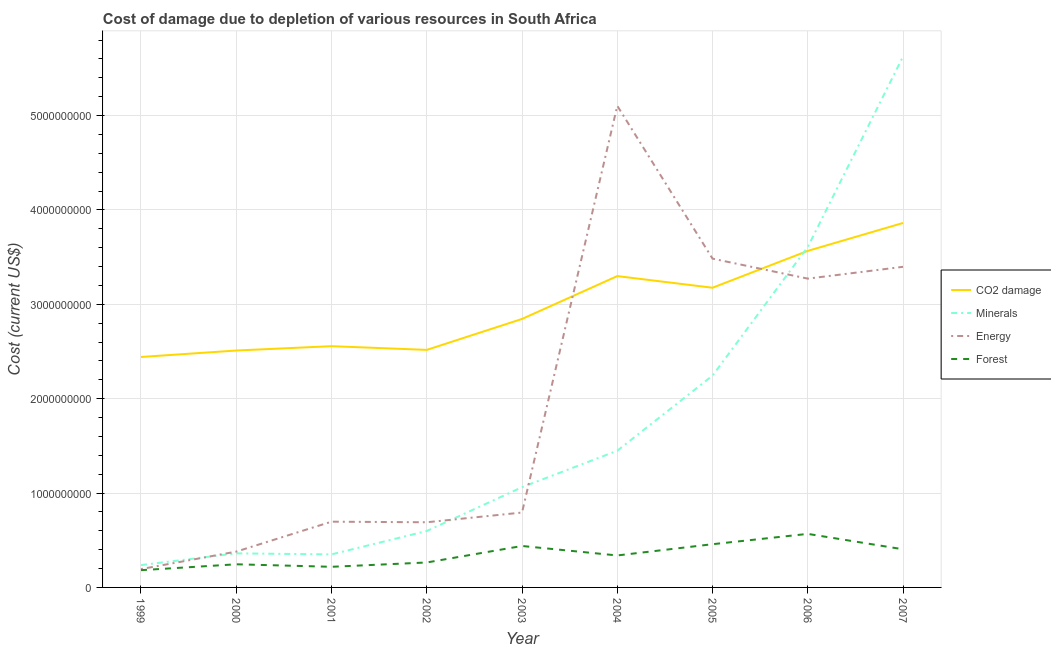Does the line corresponding to cost of damage due to depletion of forests intersect with the line corresponding to cost of damage due to depletion of coal?
Your response must be concise. No. What is the cost of damage due to depletion of minerals in 2006?
Provide a short and direct response. 3.61e+09. Across all years, what is the maximum cost of damage due to depletion of minerals?
Your answer should be compact. 5.63e+09. Across all years, what is the minimum cost of damage due to depletion of forests?
Keep it short and to the point. 1.83e+08. In which year was the cost of damage due to depletion of energy maximum?
Keep it short and to the point. 2004. What is the total cost of damage due to depletion of energy in the graph?
Your answer should be compact. 1.80e+1. What is the difference between the cost of damage due to depletion of minerals in 2001 and that in 2007?
Keep it short and to the point. -5.28e+09. What is the difference between the cost of damage due to depletion of minerals in 2000 and the cost of damage due to depletion of energy in 2005?
Provide a short and direct response. -3.12e+09. What is the average cost of damage due to depletion of minerals per year?
Your answer should be compact. 1.73e+09. In the year 2007, what is the difference between the cost of damage due to depletion of minerals and cost of damage due to depletion of energy?
Offer a very short reply. 2.23e+09. What is the ratio of the cost of damage due to depletion of coal in 2000 to that in 2005?
Make the answer very short. 0.79. Is the cost of damage due to depletion of energy in 2001 less than that in 2007?
Your answer should be compact. Yes. Is the difference between the cost of damage due to depletion of coal in 2004 and 2007 greater than the difference between the cost of damage due to depletion of energy in 2004 and 2007?
Your answer should be very brief. No. What is the difference between the highest and the second highest cost of damage due to depletion of minerals?
Your answer should be very brief. 2.02e+09. What is the difference between the highest and the lowest cost of damage due to depletion of coal?
Keep it short and to the point. 1.42e+09. Is the sum of the cost of damage due to depletion of energy in 2003 and 2005 greater than the maximum cost of damage due to depletion of minerals across all years?
Provide a short and direct response. No. Is it the case that in every year, the sum of the cost of damage due to depletion of coal and cost of damage due to depletion of forests is greater than the sum of cost of damage due to depletion of energy and cost of damage due to depletion of minerals?
Offer a terse response. No. Is it the case that in every year, the sum of the cost of damage due to depletion of coal and cost of damage due to depletion of minerals is greater than the cost of damage due to depletion of energy?
Make the answer very short. No. Is the cost of damage due to depletion of minerals strictly less than the cost of damage due to depletion of coal over the years?
Ensure brevity in your answer.  No. How many lines are there?
Keep it short and to the point. 4. Does the graph contain grids?
Provide a succinct answer. Yes. Where does the legend appear in the graph?
Provide a short and direct response. Center right. How many legend labels are there?
Your answer should be compact. 4. What is the title of the graph?
Ensure brevity in your answer.  Cost of damage due to depletion of various resources in South Africa . Does "Periodicity assessment" appear as one of the legend labels in the graph?
Your response must be concise. No. What is the label or title of the Y-axis?
Make the answer very short. Cost (current US$). What is the Cost (current US$) of CO2 damage in 1999?
Give a very brief answer. 2.44e+09. What is the Cost (current US$) in Minerals in 1999?
Provide a succinct answer. 2.37e+08. What is the Cost (current US$) of Energy in 1999?
Your answer should be very brief. 1.94e+08. What is the Cost (current US$) of Forest in 1999?
Ensure brevity in your answer.  1.83e+08. What is the Cost (current US$) of CO2 damage in 2000?
Your answer should be very brief. 2.51e+09. What is the Cost (current US$) of Minerals in 2000?
Give a very brief answer. 3.61e+08. What is the Cost (current US$) in Energy in 2000?
Make the answer very short. 3.80e+08. What is the Cost (current US$) of Forest in 2000?
Keep it short and to the point. 2.45e+08. What is the Cost (current US$) in CO2 damage in 2001?
Ensure brevity in your answer.  2.56e+09. What is the Cost (current US$) in Minerals in 2001?
Give a very brief answer. 3.50e+08. What is the Cost (current US$) of Energy in 2001?
Make the answer very short. 6.97e+08. What is the Cost (current US$) in Forest in 2001?
Provide a succinct answer. 2.19e+08. What is the Cost (current US$) in CO2 damage in 2002?
Give a very brief answer. 2.52e+09. What is the Cost (current US$) of Minerals in 2002?
Your answer should be compact. 5.98e+08. What is the Cost (current US$) in Energy in 2002?
Your answer should be compact. 6.91e+08. What is the Cost (current US$) in Forest in 2002?
Your answer should be compact. 2.64e+08. What is the Cost (current US$) in CO2 damage in 2003?
Your answer should be compact. 2.85e+09. What is the Cost (current US$) of Minerals in 2003?
Make the answer very short. 1.06e+09. What is the Cost (current US$) of Energy in 2003?
Provide a short and direct response. 7.94e+08. What is the Cost (current US$) in Forest in 2003?
Ensure brevity in your answer.  4.39e+08. What is the Cost (current US$) in CO2 damage in 2004?
Provide a succinct answer. 3.30e+09. What is the Cost (current US$) in Minerals in 2004?
Keep it short and to the point. 1.45e+09. What is the Cost (current US$) of Energy in 2004?
Make the answer very short. 5.10e+09. What is the Cost (current US$) of Forest in 2004?
Your response must be concise. 3.39e+08. What is the Cost (current US$) of CO2 damage in 2005?
Provide a short and direct response. 3.18e+09. What is the Cost (current US$) in Minerals in 2005?
Offer a very short reply. 2.24e+09. What is the Cost (current US$) in Energy in 2005?
Give a very brief answer. 3.48e+09. What is the Cost (current US$) of Forest in 2005?
Make the answer very short. 4.58e+08. What is the Cost (current US$) of CO2 damage in 2006?
Keep it short and to the point. 3.57e+09. What is the Cost (current US$) in Minerals in 2006?
Your answer should be compact. 3.61e+09. What is the Cost (current US$) of Energy in 2006?
Offer a terse response. 3.27e+09. What is the Cost (current US$) of Forest in 2006?
Offer a terse response. 5.67e+08. What is the Cost (current US$) in CO2 damage in 2007?
Your answer should be very brief. 3.86e+09. What is the Cost (current US$) in Minerals in 2007?
Your answer should be very brief. 5.63e+09. What is the Cost (current US$) in Energy in 2007?
Ensure brevity in your answer.  3.40e+09. What is the Cost (current US$) of Forest in 2007?
Give a very brief answer. 4.04e+08. Across all years, what is the maximum Cost (current US$) of CO2 damage?
Provide a succinct answer. 3.86e+09. Across all years, what is the maximum Cost (current US$) of Minerals?
Offer a very short reply. 5.63e+09. Across all years, what is the maximum Cost (current US$) in Energy?
Ensure brevity in your answer.  5.10e+09. Across all years, what is the maximum Cost (current US$) in Forest?
Your response must be concise. 5.67e+08. Across all years, what is the minimum Cost (current US$) in CO2 damage?
Ensure brevity in your answer.  2.44e+09. Across all years, what is the minimum Cost (current US$) in Minerals?
Your response must be concise. 2.37e+08. Across all years, what is the minimum Cost (current US$) of Energy?
Your answer should be compact. 1.94e+08. Across all years, what is the minimum Cost (current US$) in Forest?
Provide a succinct answer. 1.83e+08. What is the total Cost (current US$) of CO2 damage in the graph?
Offer a very short reply. 2.68e+1. What is the total Cost (current US$) in Minerals in the graph?
Ensure brevity in your answer.  1.55e+1. What is the total Cost (current US$) in Energy in the graph?
Keep it short and to the point. 1.80e+1. What is the total Cost (current US$) in Forest in the graph?
Offer a very short reply. 3.12e+09. What is the difference between the Cost (current US$) of CO2 damage in 1999 and that in 2000?
Give a very brief answer. -6.84e+07. What is the difference between the Cost (current US$) of Minerals in 1999 and that in 2000?
Offer a very short reply. -1.24e+08. What is the difference between the Cost (current US$) in Energy in 1999 and that in 2000?
Your answer should be compact. -1.85e+08. What is the difference between the Cost (current US$) in Forest in 1999 and that in 2000?
Your answer should be compact. -6.24e+07. What is the difference between the Cost (current US$) of CO2 damage in 1999 and that in 2001?
Your answer should be very brief. -1.14e+08. What is the difference between the Cost (current US$) of Minerals in 1999 and that in 2001?
Provide a succinct answer. -1.13e+08. What is the difference between the Cost (current US$) in Energy in 1999 and that in 2001?
Offer a terse response. -5.02e+08. What is the difference between the Cost (current US$) in Forest in 1999 and that in 2001?
Your answer should be compact. -3.59e+07. What is the difference between the Cost (current US$) in CO2 damage in 1999 and that in 2002?
Provide a succinct answer. -7.52e+07. What is the difference between the Cost (current US$) of Minerals in 1999 and that in 2002?
Keep it short and to the point. -3.61e+08. What is the difference between the Cost (current US$) of Energy in 1999 and that in 2002?
Offer a very short reply. -4.96e+08. What is the difference between the Cost (current US$) of Forest in 1999 and that in 2002?
Offer a very short reply. -8.16e+07. What is the difference between the Cost (current US$) of CO2 damage in 1999 and that in 2003?
Your answer should be very brief. -4.03e+08. What is the difference between the Cost (current US$) in Minerals in 1999 and that in 2003?
Provide a succinct answer. -8.25e+08. What is the difference between the Cost (current US$) of Energy in 1999 and that in 2003?
Your response must be concise. -5.99e+08. What is the difference between the Cost (current US$) in Forest in 1999 and that in 2003?
Your answer should be very brief. -2.56e+08. What is the difference between the Cost (current US$) in CO2 damage in 1999 and that in 2004?
Give a very brief answer. -8.57e+08. What is the difference between the Cost (current US$) in Minerals in 1999 and that in 2004?
Your answer should be compact. -1.21e+09. What is the difference between the Cost (current US$) in Energy in 1999 and that in 2004?
Keep it short and to the point. -4.91e+09. What is the difference between the Cost (current US$) of Forest in 1999 and that in 2004?
Ensure brevity in your answer.  -1.56e+08. What is the difference between the Cost (current US$) of CO2 damage in 1999 and that in 2005?
Offer a terse response. -7.34e+08. What is the difference between the Cost (current US$) of Minerals in 1999 and that in 2005?
Ensure brevity in your answer.  -2.01e+09. What is the difference between the Cost (current US$) of Energy in 1999 and that in 2005?
Your response must be concise. -3.29e+09. What is the difference between the Cost (current US$) in Forest in 1999 and that in 2005?
Offer a very short reply. -2.75e+08. What is the difference between the Cost (current US$) in CO2 damage in 1999 and that in 2006?
Keep it short and to the point. -1.12e+09. What is the difference between the Cost (current US$) of Minerals in 1999 and that in 2006?
Your answer should be very brief. -3.37e+09. What is the difference between the Cost (current US$) of Energy in 1999 and that in 2006?
Your response must be concise. -3.08e+09. What is the difference between the Cost (current US$) of Forest in 1999 and that in 2006?
Ensure brevity in your answer.  -3.85e+08. What is the difference between the Cost (current US$) of CO2 damage in 1999 and that in 2007?
Offer a terse response. -1.42e+09. What is the difference between the Cost (current US$) in Minerals in 1999 and that in 2007?
Give a very brief answer. -5.39e+09. What is the difference between the Cost (current US$) in Energy in 1999 and that in 2007?
Your response must be concise. -3.20e+09. What is the difference between the Cost (current US$) of Forest in 1999 and that in 2007?
Your answer should be compact. -2.21e+08. What is the difference between the Cost (current US$) in CO2 damage in 2000 and that in 2001?
Make the answer very short. -4.60e+07. What is the difference between the Cost (current US$) in Minerals in 2000 and that in 2001?
Keep it short and to the point. 1.09e+07. What is the difference between the Cost (current US$) of Energy in 2000 and that in 2001?
Offer a terse response. -3.17e+08. What is the difference between the Cost (current US$) of Forest in 2000 and that in 2001?
Give a very brief answer. 2.66e+07. What is the difference between the Cost (current US$) of CO2 damage in 2000 and that in 2002?
Your answer should be very brief. -6.77e+06. What is the difference between the Cost (current US$) of Minerals in 2000 and that in 2002?
Provide a short and direct response. -2.37e+08. What is the difference between the Cost (current US$) of Energy in 2000 and that in 2002?
Give a very brief answer. -3.11e+08. What is the difference between the Cost (current US$) of Forest in 2000 and that in 2002?
Your answer should be compact. -1.91e+07. What is the difference between the Cost (current US$) in CO2 damage in 2000 and that in 2003?
Give a very brief answer. -3.35e+08. What is the difference between the Cost (current US$) in Minerals in 2000 and that in 2003?
Provide a short and direct response. -7.01e+08. What is the difference between the Cost (current US$) of Energy in 2000 and that in 2003?
Offer a very short reply. -4.14e+08. What is the difference between the Cost (current US$) in Forest in 2000 and that in 2003?
Your response must be concise. -1.94e+08. What is the difference between the Cost (current US$) in CO2 damage in 2000 and that in 2004?
Offer a very short reply. -7.89e+08. What is the difference between the Cost (current US$) in Minerals in 2000 and that in 2004?
Offer a terse response. -1.09e+09. What is the difference between the Cost (current US$) of Energy in 2000 and that in 2004?
Your answer should be compact. -4.72e+09. What is the difference between the Cost (current US$) of Forest in 2000 and that in 2004?
Make the answer very short. -9.36e+07. What is the difference between the Cost (current US$) of CO2 damage in 2000 and that in 2005?
Your answer should be compact. -6.65e+08. What is the difference between the Cost (current US$) in Minerals in 2000 and that in 2005?
Your answer should be compact. -1.88e+09. What is the difference between the Cost (current US$) in Energy in 2000 and that in 2005?
Make the answer very short. -3.10e+09. What is the difference between the Cost (current US$) of Forest in 2000 and that in 2005?
Provide a succinct answer. -2.13e+08. What is the difference between the Cost (current US$) in CO2 damage in 2000 and that in 2006?
Provide a succinct answer. -1.06e+09. What is the difference between the Cost (current US$) in Minerals in 2000 and that in 2006?
Ensure brevity in your answer.  -3.25e+09. What is the difference between the Cost (current US$) of Energy in 2000 and that in 2006?
Your response must be concise. -2.89e+09. What is the difference between the Cost (current US$) of Forest in 2000 and that in 2006?
Provide a short and direct response. -3.22e+08. What is the difference between the Cost (current US$) of CO2 damage in 2000 and that in 2007?
Offer a very short reply. -1.35e+09. What is the difference between the Cost (current US$) of Minerals in 2000 and that in 2007?
Provide a short and direct response. -5.27e+09. What is the difference between the Cost (current US$) of Energy in 2000 and that in 2007?
Ensure brevity in your answer.  -3.02e+09. What is the difference between the Cost (current US$) of Forest in 2000 and that in 2007?
Provide a short and direct response. -1.59e+08. What is the difference between the Cost (current US$) of CO2 damage in 2001 and that in 2002?
Provide a succinct answer. 3.92e+07. What is the difference between the Cost (current US$) of Minerals in 2001 and that in 2002?
Make the answer very short. -2.48e+08. What is the difference between the Cost (current US$) of Energy in 2001 and that in 2002?
Your answer should be compact. 6.14e+06. What is the difference between the Cost (current US$) in Forest in 2001 and that in 2002?
Make the answer very short. -4.57e+07. What is the difference between the Cost (current US$) of CO2 damage in 2001 and that in 2003?
Your answer should be very brief. -2.89e+08. What is the difference between the Cost (current US$) in Minerals in 2001 and that in 2003?
Ensure brevity in your answer.  -7.12e+08. What is the difference between the Cost (current US$) of Energy in 2001 and that in 2003?
Provide a short and direct response. -9.69e+07. What is the difference between the Cost (current US$) of Forest in 2001 and that in 2003?
Provide a short and direct response. -2.21e+08. What is the difference between the Cost (current US$) in CO2 damage in 2001 and that in 2004?
Offer a very short reply. -7.43e+08. What is the difference between the Cost (current US$) in Minerals in 2001 and that in 2004?
Offer a terse response. -1.10e+09. What is the difference between the Cost (current US$) in Energy in 2001 and that in 2004?
Give a very brief answer. -4.41e+09. What is the difference between the Cost (current US$) of Forest in 2001 and that in 2004?
Provide a succinct answer. -1.20e+08. What is the difference between the Cost (current US$) in CO2 damage in 2001 and that in 2005?
Provide a succinct answer. -6.19e+08. What is the difference between the Cost (current US$) of Minerals in 2001 and that in 2005?
Provide a short and direct response. -1.89e+09. What is the difference between the Cost (current US$) of Energy in 2001 and that in 2005?
Offer a terse response. -2.79e+09. What is the difference between the Cost (current US$) in Forest in 2001 and that in 2005?
Make the answer very short. -2.39e+08. What is the difference between the Cost (current US$) in CO2 damage in 2001 and that in 2006?
Make the answer very short. -1.01e+09. What is the difference between the Cost (current US$) in Minerals in 2001 and that in 2006?
Ensure brevity in your answer.  -3.26e+09. What is the difference between the Cost (current US$) of Energy in 2001 and that in 2006?
Give a very brief answer. -2.58e+09. What is the difference between the Cost (current US$) of Forest in 2001 and that in 2006?
Your answer should be very brief. -3.49e+08. What is the difference between the Cost (current US$) of CO2 damage in 2001 and that in 2007?
Your answer should be compact. -1.31e+09. What is the difference between the Cost (current US$) in Minerals in 2001 and that in 2007?
Keep it short and to the point. -5.28e+09. What is the difference between the Cost (current US$) in Energy in 2001 and that in 2007?
Offer a terse response. -2.70e+09. What is the difference between the Cost (current US$) in Forest in 2001 and that in 2007?
Ensure brevity in your answer.  -1.85e+08. What is the difference between the Cost (current US$) in CO2 damage in 2002 and that in 2003?
Offer a terse response. -3.28e+08. What is the difference between the Cost (current US$) in Minerals in 2002 and that in 2003?
Your answer should be very brief. -4.64e+08. What is the difference between the Cost (current US$) in Energy in 2002 and that in 2003?
Ensure brevity in your answer.  -1.03e+08. What is the difference between the Cost (current US$) in Forest in 2002 and that in 2003?
Your response must be concise. -1.75e+08. What is the difference between the Cost (current US$) in CO2 damage in 2002 and that in 2004?
Ensure brevity in your answer.  -7.82e+08. What is the difference between the Cost (current US$) of Minerals in 2002 and that in 2004?
Your response must be concise. -8.51e+08. What is the difference between the Cost (current US$) in Energy in 2002 and that in 2004?
Make the answer very short. -4.41e+09. What is the difference between the Cost (current US$) of Forest in 2002 and that in 2004?
Offer a very short reply. -7.44e+07. What is the difference between the Cost (current US$) of CO2 damage in 2002 and that in 2005?
Give a very brief answer. -6.59e+08. What is the difference between the Cost (current US$) of Minerals in 2002 and that in 2005?
Offer a terse response. -1.65e+09. What is the difference between the Cost (current US$) in Energy in 2002 and that in 2005?
Your response must be concise. -2.79e+09. What is the difference between the Cost (current US$) in Forest in 2002 and that in 2005?
Keep it short and to the point. -1.94e+08. What is the difference between the Cost (current US$) in CO2 damage in 2002 and that in 2006?
Give a very brief answer. -1.05e+09. What is the difference between the Cost (current US$) in Minerals in 2002 and that in 2006?
Offer a very short reply. -3.01e+09. What is the difference between the Cost (current US$) in Energy in 2002 and that in 2006?
Give a very brief answer. -2.58e+09. What is the difference between the Cost (current US$) of Forest in 2002 and that in 2006?
Your response must be concise. -3.03e+08. What is the difference between the Cost (current US$) in CO2 damage in 2002 and that in 2007?
Your answer should be compact. -1.34e+09. What is the difference between the Cost (current US$) in Minerals in 2002 and that in 2007?
Keep it short and to the point. -5.03e+09. What is the difference between the Cost (current US$) of Energy in 2002 and that in 2007?
Provide a succinct answer. -2.71e+09. What is the difference between the Cost (current US$) in Forest in 2002 and that in 2007?
Give a very brief answer. -1.40e+08. What is the difference between the Cost (current US$) of CO2 damage in 2003 and that in 2004?
Provide a succinct answer. -4.54e+08. What is the difference between the Cost (current US$) in Minerals in 2003 and that in 2004?
Provide a succinct answer. -3.87e+08. What is the difference between the Cost (current US$) of Energy in 2003 and that in 2004?
Ensure brevity in your answer.  -4.31e+09. What is the difference between the Cost (current US$) of Forest in 2003 and that in 2004?
Provide a succinct answer. 1.00e+08. What is the difference between the Cost (current US$) of CO2 damage in 2003 and that in 2005?
Provide a short and direct response. -3.31e+08. What is the difference between the Cost (current US$) of Minerals in 2003 and that in 2005?
Give a very brief answer. -1.18e+09. What is the difference between the Cost (current US$) of Energy in 2003 and that in 2005?
Give a very brief answer. -2.69e+09. What is the difference between the Cost (current US$) of Forest in 2003 and that in 2005?
Your answer should be compact. -1.89e+07. What is the difference between the Cost (current US$) in CO2 damage in 2003 and that in 2006?
Give a very brief answer. -7.21e+08. What is the difference between the Cost (current US$) in Minerals in 2003 and that in 2006?
Give a very brief answer. -2.55e+09. What is the difference between the Cost (current US$) in Energy in 2003 and that in 2006?
Provide a short and direct response. -2.48e+09. What is the difference between the Cost (current US$) of Forest in 2003 and that in 2006?
Keep it short and to the point. -1.28e+08. What is the difference between the Cost (current US$) of CO2 damage in 2003 and that in 2007?
Make the answer very short. -1.02e+09. What is the difference between the Cost (current US$) of Minerals in 2003 and that in 2007?
Your response must be concise. -4.56e+09. What is the difference between the Cost (current US$) in Energy in 2003 and that in 2007?
Provide a succinct answer. -2.60e+09. What is the difference between the Cost (current US$) of Forest in 2003 and that in 2007?
Offer a terse response. 3.50e+07. What is the difference between the Cost (current US$) of CO2 damage in 2004 and that in 2005?
Keep it short and to the point. 1.23e+08. What is the difference between the Cost (current US$) in Minerals in 2004 and that in 2005?
Keep it short and to the point. -7.96e+08. What is the difference between the Cost (current US$) in Energy in 2004 and that in 2005?
Ensure brevity in your answer.  1.62e+09. What is the difference between the Cost (current US$) in Forest in 2004 and that in 2005?
Provide a succinct answer. -1.19e+08. What is the difference between the Cost (current US$) in CO2 damage in 2004 and that in 2006?
Your response must be concise. -2.67e+08. What is the difference between the Cost (current US$) of Minerals in 2004 and that in 2006?
Your answer should be very brief. -2.16e+09. What is the difference between the Cost (current US$) in Energy in 2004 and that in 2006?
Your answer should be very brief. 1.83e+09. What is the difference between the Cost (current US$) in Forest in 2004 and that in 2006?
Ensure brevity in your answer.  -2.29e+08. What is the difference between the Cost (current US$) of CO2 damage in 2004 and that in 2007?
Provide a short and direct response. -5.63e+08. What is the difference between the Cost (current US$) in Minerals in 2004 and that in 2007?
Make the answer very short. -4.18e+09. What is the difference between the Cost (current US$) of Energy in 2004 and that in 2007?
Offer a very short reply. 1.71e+09. What is the difference between the Cost (current US$) of Forest in 2004 and that in 2007?
Your answer should be compact. -6.54e+07. What is the difference between the Cost (current US$) in CO2 damage in 2005 and that in 2006?
Provide a succinct answer. -3.91e+08. What is the difference between the Cost (current US$) in Minerals in 2005 and that in 2006?
Offer a terse response. -1.36e+09. What is the difference between the Cost (current US$) of Energy in 2005 and that in 2006?
Your answer should be very brief. 2.12e+08. What is the difference between the Cost (current US$) of Forest in 2005 and that in 2006?
Give a very brief answer. -1.09e+08. What is the difference between the Cost (current US$) in CO2 damage in 2005 and that in 2007?
Make the answer very short. -6.86e+08. What is the difference between the Cost (current US$) of Minerals in 2005 and that in 2007?
Offer a terse response. -3.38e+09. What is the difference between the Cost (current US$) in Energy in 2005 and that in 2007?
Ensure brevity in your answer.  8.63e+07. What is the difference between the Cost (current US$) in Forest in 2005 and that in 2007?
Provide a short and direct response. 5.39e+07. What is the difference between the Cost (current US$) of CO2 damage in 2006 and that in 2007?
Your response must be concise. -2.96e+08. What is the difference between the Cost (current US$) of Minerals in 2006 and that in 2007?
Give a very brief answer. -2.02e+09. What is the difference between the Cost (current US$) of Energy in 2006 and that in 2007?
Provide a succinct answer. -1.25e+08. What is the difference between the Cost (current US$) in Forest in 2006 and that in 2007?
Make the answer very short. 1.63e+08. What is the difference between the Cost (current US$) in CO2 damage in 1999 and the Cost (current US$) in Minerals in 2000?
Your answer should be compact. 2.08e+09. What is the difference between the Cost (current US$) of CO2 damage in 1999 and the Cost (current US$) of Energy in 2000?
Make the answer very short. 2.06e+09. What is the difference between the Cost (current US$) of CO2 damage in 1999 and the Cost (current US$) of Forest in 2000?
Keep it short and to the point. 2.20e+09. What is the difference between the Cost (current US$) of Minerals in 1999 and the Cost (current US$) of Energy in 2000?
Your answer should be very brief. -1.43e+08. What is the difference between the Cost (current US$) of Minerals in 1999 and the Cost (current US$) of Forest in 2000?
Provide a succinct answer. -8.40e+06. What is the difference between the Cost (current US$) in Energy in 1999 and the Cost (current US$) in Forest in 2000?
Provide a short and direct response. -5.09e+07. What is the difference between the Cost (current US$) of CO2 damage in 1999 and the Cost (current US$) of Minerals in 2001?
Provide a short and direct response. 2.09e+09. What is the difference between the Cost (current US$) in CO2 damage in 1999 and the Cost (current US$) in Energy in 2001?
Give a very brief answer. 1.75e+09. What is the difference between the Cost (current US$) in CO2 damage in 1999 and the Cost (current US$) in Forest in 2001?
Make the answer very short. 2.22e+09. What is the difference between the Cost (current US$) of Minerals in 1999 and the Cost (current US$) of Energy in 2001?
Your answer should be very brief. -4.60e+08. What is the difference between the Cost (current US$) in Minerals in 1999 and the Cost (current US$) in Forest in 2001?
Your answer should be very brief. 1.82e+07. What is the difference between the Cost (current US$) of Energy in 1999 and the Cost (current US$) of Forest in 2001?
Offer a terse response. -2.43e+07. What is the difference between the Cost (current US$) in CO2 damage in 1999 and the Cost (current US$) in Minerals in 2002?
Provide a succinct answer. 1.84e+09. What is the difference between the Cost (current US$) of CO2 damage in 1999 and the Cost (current US$) of Energy in 2002?
Ensure brevity in your answer.  1.75e+09. What is the difference between the Cost (current US$) in CO2 damage in 1999 and the Cost (current US$) in Forest in 2002?
Provide a succinct answer. 2.18e+09. What is the difference between the Cost (current US$) in Minerals in 1999 and the Cost (current US$) in Energy in 2002?
Provide a succinct answer. -4.54e+08. What is the difference between the Cost (current US$) in Minerals in 1999 and the Cost (current US$) in Forest in 2002?
Give a very brief answer. -2.76e+07. What is the difference between the Cost (current US$) of Energy in 1999 and the Cost (current US$) of Forest in 2002?
Provide a short and direct response. -7.00e+07. What is the difference between the Cost (current US$) of CO2 damage in 1999 and the Cost (current US$) of Minerals in 2003?
Provide a short and direct response. 1.38e+09. What is the difference between the Cost (current US$) in CO2 damage in 1999 and the Cost (current US$) in Energy in 2003?
Provide a short and direct response. 1.65e+09. What is the difference between the Cost (current US$) in CO2 damage in 1999 and the Cost (current US$) in Forest in 2003?
Give a very brief answer. 2.00e+09. What is the difference between the Cost (current US$) of Minerals in 1999 and the Cost (current US$) of Energy in 2003?
Offer a very short reply. -5.57e+08. What is the difference between the Cost (current US$) of Minerals in 1999 and the Cost (current US$) of Forest in 2003?
Your answer should be compact. -2.02e+08. What is the difference between the Cost (current US$) of Energy in 1999 and the Cost (current US$) of Forest in 2003?
Give a very brief answer. -2.45e+08. What is the difference between the Cost (current US$) of CO2 damage in 1999 and the Cost (current US$) of Minerals in 2004?
Your answer should be very brief. 9.93e+08. What is the difference between the Cost (current US$) of CO2 damage in 1999 and the Cost (current US$) of Energy in 2004?
Your answer should be very brief. -2.66e+09. What is the difference between the Cost (current US$) in CO2 damage in 1999 and the Cost (current US$) in Forest in 2004?
Offer a very short reply. 2.10e+09. What is the difference between the Cost (current US$) of Minerals in 1999 and the Cost (current US$) of Energy in 2004?
Offer a terse response. -4.87e+09. What is the difference between the Cost (current US$) in Minerals in 1999 and the Cost (current US$) in Forest in 2004?
Give a very brief answer. -1.02e+08. What is the difference between the Cost (current US$) of Energy in 1999 and the Cost (current US$) of Forest in 2004?
Provide a short and direct response. -1.44e+08. What is the difference between the Cost (current US$) in CO2 damage in 1999 and the Cost (current US$) in Minerals in 2005?
Your answer should be very brief. 1.98e+08. What is the difference between the Cost (current US$) in CO2 damage in 1999 and the Cost (current US$) in Energy in 2005?
Make the answer very short. -1.04e+09. What is the difference between the Cost (current US$) of CO2 damage in 1999 and the Cost (current US$) of Forest in 2005?
Ensure brevity in your answer.  1.98e+09. What is the difference between the Cost (current US$) of Minerals in 1999 and the Cost (current US$) of Energy in 2005?
Provide a short and direct response. -3.25e+09. What is the difference between the Cost (current US$) of Minerals in 1999 and the Cost (current US$) of Forest in 2005?
Offer a terse response. -2.21e+08. What is the difference between the Cost (current US$) of Energy in 1999 and the Cost (current US$) of Forest in 2005?
Keep it short and to the point. -2.64e+08. What is the difference between the Cost (current US$) in CO2 damage in 1999 and the Cost (current US$) in Minerals in 2006?
Give a very brief answer. -1.17e+09. What is the difference between the Cost (current US$) of CO2 damage in 1999 and the Cost (current US$) of Energy in 2006?
Keep it short and to the point. -8.30e+08. What is the difference between the Cost (current US$) of CO2 damage in 1999 and the Cost (current US$) of Forest in 2006?
Ensure brevity in your answer.  1.87e+09. What is the difference between the Cost (current US$) of Minerals in 1999 and the Cost (current US$) of Energy in 2006?
Ensure brevity in your answer.  -3.04e+09. What is the difference between the Cost (current US$) of Minerals in 1999 and the Cost (current US$) of Forest in 2006?
Provide a short and direct response. -3.31e+08. What is the difference between the Cost (current US$) in Energy in 1999 and the Cost (current US$) in Forest in 2006?
Offer a very short reply. -3.73e+08. What is the difference between the Cost (current US$) of CO2 damage in 1999 and the Cost (current US$) of Minerals in 2007?
Provide a short and direct response. -3.18e+09. What is the difference between the Cost (current US$) of CO2 damage in 1999 and the Cost (current US$) of Energy in 2007?
Ensure brevity in your answer.  -9.56e+08. What is the difference between the Cost (current US$) in CO2 damage in 1999 and the Cost (current US$) in Forest in 2007?
Your answer should be compact. 2.04e+09. What is the difference between the Cost (current US$) in Minerals in 1999 and the Cost (current US$) in Energy in 2007?
Make the answer very short. -3.16e+09. What is the difference between the Cost (current US$) of Minerals in 1999 and the Cost (current US$) of Forest in 2007?
Your answer should be very brief. -1.67e+08. What is the difference between the Cost (current US$) in Energy in 1999 and the Cost (current US$) in Forest in 2007?
Give a very brief answer. -2.10e+08. What is the difference between the Cost (current US$) in CO2 damage in 2000 and the Cost (current US$) in Minerals in 2001?
Ensure brevity in your answer.  2.16e+09. What is the difference between the Cost (current US$) in CO2 damage in 2000 and the Cost (current US$) in Energy in 2001?
Keep it short and to the point. 1.81e+09. What is the difference between the Cost (current US$) in CO2 damage in 2000 and the Cost (current US$) in Forest in 2001?
Your response must be concise. 2.29e+09. What is the difference between the Cost (current US$) in Minerals in 2000 and the Cost (current US$) in Energy in 2001?
Your answer should be very brief. -3.36e+08. What is the difference between the Cost (current US$) in Minerals in 2000 and the Cost (current US$) in Forest in 2001?
Provide a short and direct response. 1.42e+08. What is the difference between the Cost (current US$) in Energy in 2000 and the Cost (current US$) in Forest in 2001?
Provide a succinct answer. 1.61e+08. What is the difference between the Cost (current US$) in CO2 damage in 2000 and the Cost (current US$) in Minerals in 2002?
Keep it short and to the point. 1.91e+09. What is the difference between the Cost (current US$) of CO2 damage in 2000 and the Cost (current US$) of Energy in 2002?
Keep it short and to the point. 1.82e+09. What is the difference between the Cost (current US$) of CO2 damage in 2000 and the Cost (current US$) of Forest in 2002?
Your response must be concise. 2.25e+09. What is the difference between the Cost (current US$) in Minerals in 2000 and the Cost (current US$) in Energy in 2002?
Provide a short and direct response. -3.30e+08. What is the difference between the Cost (current US$) in Minerals in 2000 and the Cost (current US$) in Forest in 2002?
Give a very brief answer. 9.66e+07. What is the difference between the Cost (current US$) of Energy in 2000 and the Cost (current US$) of Forest in 2002?
Offer a very short reply. 1.15e+08. What is the difference between the Cost (current US$) in CO2 damage in 2000 and the Cost (current US$) in Minerals in 2003?
Offer a very short reply. 1.45e+09. What is the difference between the Cost (current US$) of CO2 damage in 2000 and the Cost (current US$) of Energy in 2003?
Give a very brief answer. 1.72e+09. What is the difference between the Cost (current US$) of CO2 damage in 2000 and the Cost (current US$) of Forest in 2003?
Your answer should be very brief. 2.07e+09. What is the difference between the Cost (current US$) of Minerals in 2000 and the Cost (current US$) of Energy in 2003?
Your answer should be very brief. -4.33e+08. What is the difference between the Cost (current US$) in Minerals in 2000 and the Cost (current US$) in Forest in 2003?
Offer a terse response. -7.82e+07. What is the difference between the Cost (current US$) of Energy in 2000 and the Cost (current US$) of Forest in 2003?
Provide a succinct answer. -5.95e+07. What is the difference between the Cost (current US$) in CO2 damage in 2000 and the Cost (current US$) in Minerals in 2004?
Offer a terse response. 1.06e+09. What is the difference between the Cost (current US$) of CO2 damage in 2000 and the Cost (current US$) of Energy in 2004?
Provide a short and direct response. -2.59e+09. What is the difference between the Cost (current US$) in CO2 damage in 2000 and the Cost (current US$) in Forest in 2004?
Offer a very short reply. 2.17e+09. What is the difference between the Cost (current US$) of Minerals in 2000 and the Cost (current US$) of Energy in 2004?
Your answer should be compact. -4.74e+09. What is the difference between the Cost (current US$) of Minerals in 2000 and the Cost (current US$) of Forest in 2004?
Ensure brevity in your answer.  2.22e+07. What is the difference between the Cost (current US$) in Energy in 2000 and the Cost (current US$) in Forest in 2004?
Ensure brevity in your answer.  4.08e+07. What is the difference between the Cost (current US$) in CO2 damage in 2000 and the Cost (current US$) in Minerals in 2005?
Keep it short and to the point. 2.66e+08. What is the difference between the Cost (current US$) of CO2 damage in 2000 and the Cost (current US$) of Energy in 2005?
Your answer should be very brief. -9.73e+08. What is the difference between the Cost (current US$) in CO2 damage in 2000 and the Cost (current US$) in Forest in 2005?
Provide a short and direct response. 2.05e+09. What is the difference between the Cost (current US$) in Minerals in 2000 and the Cost (current US$) in Energy in 2005?
Ensure brevity in your answer.  -3.12e+09. What is the difference between the Cost (current US$) of Minerals in 2000 and the Cost (current US$) of Forest in 2005?
Your answer should be very brief. -9.71e+07. What is the difference between the Cost (current US$) in Energy in 2000 and the Cost (current US$) in Forest in 2005?
Your response must be concise. -7.84e+07. What is the difference between the Cost (current US$) of CO2 damage in 2000 and the Cost (current US$) of Minerals in 2006?
Provide a succinct answer. -1.10e+09. What is the difference between the Cost (current US$) of CO2 damage in 2000 and the Cost (current US$) of Energy in 2006?
Offer a terse response. -7.62e+08. What is the difference between the Cost (current US$) of CO2 damage in 2000 and the Cost (current US$) of Forest in 2006?
Give a very brief answer. 1.94e+09. What is the difference between the Cost (current US$) of Minerals in 2000 and the Cost (current US$) of Energy in 2006?
Make the answer very short. -2.91e+09. What is the difference between the Cost (current US$) in Minerals in 2000 and the Cost (current US$) in Forest in 2006?
Offer a very short reply. -2.06e+08. What is the difference between the Cost (current US$) in Energy in 2000 and the Cost (current US$) in Forest in 2006?
Your answer should be compact. -1.88e+08. What is the difference between the Cost (current US$) of CO2 damage in 2000 and the Cost (current US$) of Minerals in 2007?
Keep it short and to the point. -3.12e+09. What is the difference between the Cost (current US$) of CO2 damage in 2000 and the Cost (current US$) of Energy in 2007?
Provide a short and direct response. -8.87e+08. What is the difference between the Cost (current US$) in CO2 damage in 2000 and the Cost (current US$) in Forest in 2007?
Provide a succinct answer. 2.11e+09. What is the difference between the Cost (current US$) in Minerals in 2000 and the Cost (current US$) in Energy in 2007?
Ensure brevity in your answer.  -3.04e+09. What is the difference between the Cost (current US$) of Minerals in 2000 and the Cost (current US$) of Forest in 2007?
Ensure brevity in your answer.  -4.32e+07. What is the difference between the Cost (current US$) of Energy in 2000 and the Cost (current US$) of Forest in 2007?
Ensure brevity in your answer.  -2.45e+07. What is the difference between the Cost (current US$) of CO2 damage in 2001 and the Cost (current US$) of Minerals in 2002?
Make the answer very short. 1.96e+09. What is the difference between the Cost (current US$) of CO2 damage in 2001 and the Cost (current US$) of Energy in 2002?
Give a very brief answer. 1.87e+09. What is the difference between the Cost (current US$) of CO2 damage in 2001 and the Cost (current US$) of Forest in 2002?
Make the answer very short. 2.29e+09. What is the difference between the Cost (current US$) in Minerals in 2001 and the Cost (current US$) in Energy in 2002?
Offer a very short reply. -3.40e+08. What is the difference between the Cost (current US$) in Minerals in 2001 and the Cost (current US$) in Forest in 2002?
Your answer should be very brief. 8.57e+07. What is the difference between the Cost (current US$) in Energy in 2001 and the Cost (current US$) in Forest in 2002?
Offer a terse response. 4.32e+08. What is the difference between the Cost (current US$) of CO2 damage in 2001 and the Cost (current US$) of Minerals in 2003?
Offer a terse response. 1.49e+09. What is the difference between the Cost (current US$) of CO2 damage in 2001 and the Cost (current US$) of Energy in 2003?
Ensure brevity in your answer.  1.76e+09. What is the difference between the Cost (current US$) of CO2 damage in 2001 and the Cost (current US$) of Forest in 2003?
Ensure brevity in your answer.  2.12e+09. What is the difference between the Cost (current US$) of Minerals in 2001 and the Cost (current US$) of Energy in 2003?
Keep it short and to the point. -4.44e+08. What is the difference between the Cost (current US$) in Minerals in 2001 and the Cost (current US$) in Forest in 2003?
Provide a short and direct response. -8.92e+07. What is the difference between the Cost (current US$) of Energy in 2001 and the Cost (current US$) of Forest in 2003?
Provide a short and direct response. 2.57e+08. What is the difference between the Cost (current US$) of CO2 damage in 2001 and the Cost (current US$) of Minerals in 2004?
Your answer should be compact. 1.11e+09. What is the difference between the Cost (current US$) in CO2 damage in 2001 and the Cost (current US$) in Energy in 2004?
Ensure brevity in your answer.  -2.55e+09. What is the difference between the Cost (current US$) of CO2 damage in 2001 and the Cost (current US$) of Forest in 2004?
Offer a terse response. 2.22e+09. What is the difference between the Cost (current US$) in Minerals in 2001 and the Cost (current US$) in Energy in 2004?
Make the answer very short. -4.75e+09. What is the difference between the Cost (current US$) in Minerals in 2001 and the Cost (current US$) in Forest in 2004?
Your response must be concise. 1.12e+07. What is the difference between the Cost (current US$) in Energy in 2001 and the Cost (current US$) in Forest in 2004?
Provide a succinct answer. 3.58e+08. What is the difference between the Cost (current US$) in CO2 damage in 2001 and the Cost (current US$) in Minerals in 2005?
Provide a succinct answer. 3.12e+08. What is the difference between the Cost (current US$) of CO2 damage in 2001 and the Cost (current US$) of Energy in 2005?
Offer a very short reply. -9.27e+08. What is the difference between the Cost (current US$) of CO2 damage in 2001 and the Cost (current US$) of Forest in 2005?
Give a very brief answer. 2.10e+09. What is the difference between the Cost (current US$) in Minerals in 2001 and the Cost (current US$) in Energy in 2005?
Provide a succinct answer. -3.13e+09. What is the difference between the Cost (current US$) of Minerals in 2001 and the Cost (current US$) of Forest in 2005?
Provide a short and direct response. -1.08e+08. What is the difference between the Cost (current US$) in Energy in 2001 and the Cost (current US$) in Forest in 2005?
Provide a succinct answer. 2.39e+08. What is the difference between the Cost (current US$) in CO2 damage in 2001 and the Cost (current US$) in Minerals in 2006?
Ensure brevity in your answer.  -1.05e+09. What is the difference between the Cost (current US$) of CO2 damage in 2001 and the Cost (current US$) of Energy in 2006?
Offer a very short reply. -7.16e+08. What is the difference between the Cost (current US$) in CO2 damage in 2001 and the Cost (current US$) in Forest in 2006?
Make the answer very short. 1.99e+09. What is the difference between the Cost (current US$) in Minerals in 2001 and the Cost (current US$) in Energy in 2006?
Provide a short and direct response. -2.92e+09. What is the difference between the Cost (current US$) of Minerals in 2001 and the Cost (current US$) of Forest in 2006?
Provide a short and direct response. -2.17e+08. What is the difference between the Cost (current US$) of Energy in 2001 and the Cost (current US$) of Forest in 2006?
Ensure brevity in your answer.  1.29e+08. What is the difference between the Cost (current US$) of CO2 damage in 2001 and the Cost (current US$) of Minerals in 2007?
Keep it short and to the point. -3.07e+09. What is the difference between the Cost (current US$) of CO2 damage in 2001 and the Cost (current US$) of Energy in 2007?
Give a very brief answer. -8.41e+08. What is the difference between the Cost (current US$) in CO2 damage in 2001 and the Cost (current US$) in Forest in 2007?
Keep it short and to the point. 2.15e+09. What is the difference between the Cost (current US$) in Minerals in 2001 and the Cost (current US$) in Energy in 2007?
Make the answer very short. -3.05e+09. What is the difference between the Cost (current US$) in Minerals in 2001 and the Cost (current US$) in Forest in 2007?
Provide a succinct answer. -5.41e+07. What is the difference between the Cost (current US$) of Energy in 2001 and the Cost (current US$) of Forest in 2007?
Offer a terse response. 2.93e+08. What is the difference between the Cost (current US$) in CO2 damage in 2002 and the Cost (current US$) in Minerals in 2003?
Your response must be concise. 1.46e+09. What is the difference between the Cost (current US$) in CO2 damage in 2002 and the Cost (current US$) in Energy in 2003?
Make the answer very short. 1.72e+09. What is the difference between the Cost (current US$) of CO2 damage in 2002 and the Cost (current US$) of Forest in 2003?
Make the answer very short. 2.08e+09. What is the difference between the Cost (current US$) of Minerals in 2002 and the Cost (current US$) of Energy in 2003?
Make the answer very short. -1.95e+08. What is the difference between the Cost (current US$) of Minerals in 2002 and the Cost (current US$) of Forest in 2003?
Give a very brief answer. 1.59e+08. What is the difference between the Cost (current US$) of Energy in 2002 and the Cost (current US$) of Forest in 2003?
Ensure brevity in your answer.  2.51e+08. What is the difference between the Cost (current US$) of CO2 damage in 2002 and the Cost (current US$) of Minerals in 2004?
Offer a terse response. 1.07e+09. What is the difference between the Cost (current US$) of CO2 damage in 2002 and the Cost (current US$) of Energy in 2004?
Provide a succinct answer. -2.59e+09. What is the difference between the Cost (current US$) of CO2 damage in 2002 and the Cost (current US$) of Forest in 2004?
Your answer should be very brief. 2.18e+09. What is the difference between the Cost (current US$) in Minerals in 2002 and the Cost (current US$) in Energy in 2004?
Keep it short and to the point. -4.51e+09. What is the difference between the Cost (current US$) in Minerals in 2002 and the Cost (current US$) in Forest in 2004?
Your answer should be very brief. 2.59e+08. What is the difference between the Cost (current US$) of Energy in 2002 and the Cost (current US$) of Forest in 2004?
Your answer should be compact. 3.52e+08. What is the difference between the Cost (current US$) in CO2 damage in 2002 and the Cost (current US$) in Minerals in 2005?
Offer a terse response. 2.73e+08. What is the difference between the Cost (current US$) in CO2 damage in 2002 and the Cost (current US$) in Energy in 2005?
Your answer should be compact. -9.67e+08. What is the difference between the Cost (current US$) in CO2 damage in 2002 and the Cost (current US$) in Forest in 2005?
Keep it short and to the point. 2.06e+09. What is the difference between the Cost (current US$) of Minerals in 2002 and the Cost (current US$) of Energy in 2005?
Keep it short and to the point. -2.89e+09. What is the difference between the Cost (current US$) in Minerals in 2002 and the Cost (current US$) in Forest in 2005?
Your answer should be very brief. 1.40e+08. What is the difference between the Cost (current US$) in Energy in 2002 and the Cost (current US$) in Forest in 2005?
Your answer should be compact. 2.32e+08. What is the difference between the Cost (current US$) of CO2 damage in 2002 and the Cost (current US$) of Minerals in 2006?
Your answer should be very brief. -1.09e+09. What is the difference between the Cost (current US$) of CO2 damage in 2002 and the Cost (current US$) of Energy in 2006?
Offer a terse response. -7.55e+08. What is the difference between the Cost (current US$) in CO2 damage in 2002 and the Cost (current US$) in Forest in 2006?
Give a very brief answer. 1.95e+09. What is the difference between the Cost (current US$) in Minerals in 2002 and the Cost (current US$) in Energy in 2006?
Your answer should be very brief. -2.67e+09. What is the difference between the Cost (current US$) in Minerals in 2002 and the Cost (current US$) in Forest in 2006?
Your answer should be compact. 3.07e+07. What is the difference between the Cost (current US$) of Energy in 2002 and the Cost (current US$) of Forest in 2006?
Offer a very short reply. 1.23e+08. What is the difference between the Cost (current US$) in CO2 damage in 2002 and the Cost (current US$) in Minerals in 2007?
Your answer should be very brief. -3.11e+09. What is the difference between the Cost (current US$) in CO2 damage in 2002 and the Cost (current US$) in Energy in 2007?
Make the answer very short. -8.80e+08. What is the difference between the Cost (current US$) in CO2 damage in 2002 and the Cost (current US$) in Forest in 2007?
Your response must be concise. 2.11e+09. What is the difference between the Cost (current US$) of Minerals in 2002 and the Cost (current US$) of Energy in 2007?
Make the answer very short. -2.80e+09. What is the difference between the Cost (current US$) in Minerals in 2002 and the Cost (current US$) in Forest in 2007?
Your answer should be compact. 1.94e+08. What is the difference between the Cost (current US$) in Energy in 2002 and the Cost (current US$) in Forest in 2007?
Your answer should be very brief. 2.86e+08. What is the difference between the Cost (current US$) of CO2 damage in 2003 and the Cost (current US$) of Minerals in 2004?
Offer a terse response. 1.40e+09. What is the difference between the Cost (current US$) in CO2 damage in 2003 and the Cost (current US$) in Energy in 2004?
Ensure brevity in your answer.  -2.26e+09. What is the difference between the Cost (current US$) of CO2 damage in 2003 and the Cost (current US$) of Forest in 2004?
Give a very brief answer. 2.51e+09. What is the difference between the Cost (current US$) of Minerals in 2003 and the Cost (current US$) of Energy in 2004?
Offer a terse response. -4.04e+09. What is the difference between the Cost (current US$) in Minerals in 2003 and the Cost (current US$) in Forest in 2004?
Your answer should be very brief. 7.23e+08. What is the difference between the Cost (current US$) in Energy in 2003 and the Cost (current US$) in Forest in 2004?
Offer a very short reply. 4.55e+08. What is the difference between the Cost (current US$) in CO2 damage in 2003 and the Cost (current US$) in Minerals in 2005?
Your response must be concise. 6.01e+08. What is the difference between the Cost (current US$) in CO2 damage in 2003 and the Cost (current US$) in Energy in 2005?
Provide a succinct answer. -6.39e+08. What is the difference between the Cost (current US$) of CO2 damage in 2003 and the Cost (current US$) of Forest in 2005?
Offer a terse response. 2.39e+09. What is the difference between the Cost (current US$) in Minerals in 2003 and the Cost (current US$) in Energy in 2005?
Ensure brevity in your answer.  -2.42e+09. What is the difference between the Cost (current US$) of Minerals in 2003 and the Cost (current US$) of Forest in 2005?
Keep it short and to the point. 6.04e+08. What is the difference between the Cost (current US$) in Energy in 2003 and the Cost (current US$) in Forest in 2005?
Keep it short and to the point. 3.36e+08. What is the difference between the Cost (current US$) of CO2 damage in 2003 and the Cost (current US$) of Minerals in 2006?
Your response must be concise. -7.63e+08. What is the difference between the Cost (current US$) in CO2 damage in 2003 and the Cost (current US$) in Energy in 2006?
Your answer should be compact. -4.27e+08. What is the difference between the Cost (current US$) in CO2 damage in 2003 and the Cost (current US$) in Forest in 2006?
Provide a succinct answer. 2.28e+09. What is the difference between the Cost (current US$) in Minerals in 2003 and the Cost (current US$) in Energy in 2006?
Provide a short and direct response. -2.21e+09. What is the difference between the Cost (current US$) in Minerals in 2003 and the Cost (current US$) in Forest in 2006?
Your answer should be very brief. 4.95e+08. What is the difference between the Cost (current US$) of Energy in 2003 and the Cost (current US$) of Forest in 2006?
Your answer should be compact. 2.26e+08. What is the difference between the Cost (current US$) of CO2 damage in 2003 and the Cost (current US$) of Minerals in 2007?
Offer a very short reply. -2.78e+09. What is the difference between the Cost (current US$) of CO2 damage in 2003 and the Cost (current US$) of Energy in 2007?
Keep it short and to the point. -5.53e+08. What is the difference between the Cost (current US$) of CO2 damage in 2003 and the Cost (current US$) of Forest in 2007?
Provide a succinct answer. 2.44e+09. What is the difference between the Cost (current US$) in Minerals in 2003 and the Cost (current US$) in Energy in 2007?
Keep it short and to the point. -2.34e+09. What is the difference between the Cost (current US$) in Minerals in 2003 and the Cost (current US$) in Forest in 2007?
Offer a terse response. 6.58e+08. What is the difference between the Cost (current US$) of Energy in 2003 and the Cost (current US$) of Forest in 2007?
Provide a succinct answer. 3.89e+08. What is the difference between the Cost (current US$) of CO2 damage in 2004 and the Cost (current US$) of Minerals in 2005?
Ensure brevity in your answer.  1.05e+09. What is the difference between the Cost (current US$) in CO2 damage in 2004 and the Cost (current US$) in Energy in 2005?
Make the answer very short. -1.85e+08. What is the difference between the Cost (current US$) in CO2 damage in 2004 and the Cost (current US$) in Forest in 2005?
Your answer should be compact. 2.84e+09. What is the difference between the Cost (current US$) in Minerals in 2004 and the Cost (current US$) in Energy in 2005?
Provide a short and direct response. -2.04e+09. What is the difference between the Cost (current US$) of Minerals in 2004 and the Cost (current US$) of Forest in 2005?
Keep it short and to the point. 9.91e+08. What is the difference between the Cost (current US$) in Energy in 2004 and the Cost (current US$) in Forest in 2005?
Provide a succinct answer. 4.65e+09. What is the difference between the Cost (current US$) in CO2 damage in 2004 and the Cost (current US$) in Minerals in 2006?
Provide a short and direct response. -3.09e+08. What is the difference between the Cost (current US$) of CO2 damage in 2004 and the Cost (current US$) of Energy in 2006?
Your response must be concise. 2.68e+07. What is the difference between the Cost (current US$) of CO2 damage in 2004 and the Cost (current US$) of Forest in 2006?
Provide a succinct answer. 2.73e+09. What is the difference between the Cost (current US$) of Minerals in 2004 and the Cost (current US$) of Energy in 2006?
Make the answer very short. -1.82e+09. What is the difference between the Cost (current US$) of Minerals in 2004 and the Cost (current US$) of Forest in 2006?
Offer a very short reply. 8.81e+08. What is the difference between the Cost (current US$) of Energy in 2004 and the Cost (current US$) of Forest in 2006?
Make the answer very short. 4.54e+09. What is the difference between the Cost (current US$) in CO2 damage in 2004 and the Cost (current US$) in Minerals in 2007?
Ensure brevity in your answer.  -2.33e+09. What is the difference between the Cost (current US$) in CO2 damage in 2004 and the Cost (current US$) in Energy in 2007?
Offer a very short reply. -9.85e+07. What is the difference between the Cost (current US$) in CO2 damage in 2004 and the Cost (current US$) in Forest in 2007?
Offer a terse response. 2.89e+09. What is the difference between the Cost (current US$) of Minerals in 2004 and the Cost (current US$) of Energy in 2007?
Keep it short and to the point. -1.95e+09. What is the difference between the Cost (current US$) of Minerals in 2004 and the Cost (current US$) of Forest in 2007?
Provide a succinct answer. 1.04e+09. What is the difference between the Cost (current US$) in Energy in 2004 and the Cost (current US$) in Forest in 2007?
Offer a terse response. 4.70e+09. What is the difference between the Cost (current US$) of CO2 damage in 2005 and the Cost (current US$) of Minerals in 2006?
Keep it short and to the point. -4.33e+08. What is the difference between the Cost (current US$) in CO2 damage in 2005 and the Cost (current US$) in Energy in 2006?
Give a very brief answer. -9.65e+07. What is the difference between the Cost (current US$) of CO2 damage in 2005 and the Cost (current US$) of Forest in 2006?
Make the answer very short. 2.61e+09. What is the difference between the Cost (current US$) of Minerals in 2005 and the Cost (current US$) of Energy in 2006?
Offer a very short reply. -1.03e+09. What is the difference between the Cost (current US$) of Minerals in 2005 and the Cost (current US$) of Forest in 2006?
Your answer should be compact. 1.68e+09. What is the difference between the Cost (current US$) in Energy in 2005 and the Cost (current US$) in Forest in 2006?
Make the answer very short. 2.92e+09. What is the difference between the Cost (current US$) of CO2 damage in 2005 and the Cost (current US$) of Minerals in 2007?
Give a very brief answer. -2.45e+09. What is the difference between the Cost (current US$) of CO2 damage in 2005 and the Cost (current US$) of Energy in 2007?
Offer a very short reply. -2.22e+08. What is the difference between the Cost (current US$) of CO2 damage in 2005 and the Cost (current US$) of Forest in 2007?
Your answer should be compact. 2.77e+09. What is the difference between the Cost (current US$) of Minerals in 2005 and the Cost (current US$) of Energy in 2007?
Your answer should be compact. -1.15e+09. What is the difference between the Cost (current US$) in Minerals in 2005 and the Cost (current US$) in Forest in 2007?
Provide a succinct answer. 1.84e+09. What is the difference between the Cost (current US$) in Energy in 2005 and the Cost (current US$) in Forest in 2007?
Offer a terse response. 3.08e+09. What is the difference between the Cost (current US$) of CO2 damage in 2006 and the Cost (current US$) of Minerals in 2007?
Your answer should be compact. -2.06e+09. What is the difference between the Cost (current US$) in CO2 damage in 2006 and the Cost (current US$) in Energy in 2007?
Offer a very short reply. 1.69e+08. What is the difference between the Cost (current US$) in CO2 damage in 2006 and the Cost (current US$) in Forest in 2007?
Offer a terse response. 3.16e+09. What is the difference between the Cost (current US$) of Minerals in 2006 and the Cost (current US$) of Energy in 2007?
Ensure brevity in your answer.  2.11e+08. What is the difference between the Cost (current US$) of Minerals in 2006 and the Cost (current US$) of Forest in 2007?
Your answer should be compact. 3.20e+09. What is the difference between the Cost (current US$) of Energy in 2006 and the Cost (current US$) of Forest in 2007?
Your response must be concise. 2.87e+09. What is the average Cost (current US$) in CO2 damage per year?
Your response must be concise. 2.98e+09. What is the average Cost (current US$) of Minerals per year?
Provide a short and direct response. 1.73e+09. What is the average Cost (current US$) of Energy per year?
Your response must be concise. 2.00e+09. What is the average Cost (current US$) of Forest per year?
Your answer should be compact. 3.47e+08. In the year 1999, what is the difference between the Cost (current US$) in CO2 damage and Cost (current US$) in Minerals?
Offer a very short reply. 2.21e+09. In the year 1999, what is the difference between the Cost (current US$) of CO2 damage and Cost (current US$) of Energy?
Ensure brevity in your answer.  2.25e+09. In the year 1999, what is the difference between the Cost (current US$) in CO2 damage and Cost (current US$) in Forest?
Your response must be concise. 2.26e+09. In the year 1999, what is the difference between the Cost (current US$) of Minerals and Cost (current US$) of Energy?
Offer a very short reply. 4.25e+07. In the year 1999, what is the difference between the Cost (current US$) of Minerals and Cost (current US$) of Forest?
Offer a very short reply. 5.40e+07. In the year 1999, what is the difference between the Cost (current US$) of Energy and Cost (current US$) of Forest?
Your answer should be very brief. 1.16e+07. In the year 2000, what is the difference between the Cost (current US$) in CO2 damage and Cost (current US$) in Minerals?
Your response must be concise. 2.15e+09. In the year 2000, what is the difference between the Cost (current US$) in CO2 damage and Cost (current US$) in Energy?
Keep it short and to the point. 2.13e+09. In the year 2000, what is the difference between the Cost (current US$) in CO2 damage and Cost (current US$) in Forest?
Ensure brevity in your answer.  2.27e+09. In the year 2000, what is the difference between the Cost (current US$) of Minerals and Cost (current US$) of Energy?
Make the answer very short. -1.87e+07. In the year 2000, what is the difference between the Cost (current US$) in Minerals and Cost (current US$) in Forest?
Offer a very short reply. 1.16e+08. In the year 2000, what is the difference between the Cost (current US$) of Energy and Cost (current US$) of Forest?
Make the answer very short. 1.34e+08. In the year 2001, what is the difference between the Cost (current US$) in CO2 damage and Cost (current US$) in Minerals?
Offer a very short reply. 2.21e+09. In the year 2001, what is the difference between the Cost (current US$) of CO2 damage and Cost (current US$) of Energy?
Provide a succinct answer. 1.86e+09. In the year 2001, what is the difference between the Cost (current US$) of CO2 damage and Cost (current US$) of Forest?
Keep it short and to the point. 2.34e+09. In the year 2001, what is the difference between the Cost (current US$) in Minerals and Cost (current US$) in Energy?
Your answer should be very brief. -3.47e+08. In the year 2001, what is the difference between the Cost (current US$) in Minerals and Cost (current US$) in Forest?
Offer a very short reply. 1.31e+08. In the year 2001, what is the difference between the Cost (current US$) in Energy and Cost (current US$) in Forest?
Provide a short and direct response. 4.78e+08. In the year 2002, what is the difference between the Cost (current US$) in CO2 damage and Cost (current US$) in Minerals?
Your response must be concise. 1.92e+09. In the year 2002, what is the difference between the Cost (current US$) in CO2 damage and Cost (current US$) in Energy?
Make the answer very short. 1.83e+09. In the year 2002, what is the difference between the Cost (current US$) of CO2 damage and Cost (current US$) of Forest?
Provide a short and direct response. 2.25e+09. In the year 2002, what is the difference between the Cost (current US$) of Minerals and Cost (current US$) of Energy?
Provide a short and direct response. -9.24e+07. In the year 2002, what is the difference between the Cost (current US$) of Minerals and Cost (current US$) of Forest?
Provide a succinct answer. 3.34e+08. In the year 2002, what is the difference between the Cost (current US$) of Energy and Cost (current US$) of Forest?
Give a very brief answer. 4.26e+08. In the year 2003, what is the difference between the Cost (current US$) of CO2 damage and Cost (current US$) of Minerals?
Offer a terse response. 1.78e+09. In the year 2003, what is the difference between the Cost (current US$) in CO2 damage and Cost (current US$) in Energy?
Keep it short and to the point. 2.05e+09. In the year 2003, what is the difference between the Cost (current US$) of CO2 damage and Cost (current US$) of Forest?
Keep it short and to the point. 2.41e+09. In the year 2003, what is the difference between the Cost (current US$) in Minerals and Cost (current US$) in Energy?
Keep it short and to the point. 2.69e+08. In the year 2003, what is the difference between the Cost (current US$) of Minerals and Cost (current US$) of Forest?
Keep it short and to the point. 6.23e+08. In the year 2003, what is the difference between the Cost (current US$) of Energy and Cost (current US$) of Forest?
Keep it short and to the point. 3.54e+08. In the year 2004, what is the difference between the Cost (current US$) in CO2 damage and Cost (current US$) in Minerals?
Provide a short and direct response. 1.85e+09. In the year 2004, what is the difference between the Cost (current US$) in CO2 damage and Cost (current US$) in Energy?
Keep it short and to the point. -1.80e+09. In the year 2004, what is the difference between the Cost (current US$) in CO2 damage and Cost (current US$) in Forest?
Your answer should be very brief. 2.96e+09. In the year 2004, what is the difference between the Cost (current US$) in Minerals and Cost (current US$) in Energy?
Offer a terse response. -3.65e+09. In the year 2004, what is the difference between the Cost (current US$) in Minerals and Cost (current US$) in Forest?
Your answer should be very brief. 1.11e+09. In the year 2004, what is the difference between the Cost (current US$) of Energy and Cost (current US$) of Forest?
Your answer should be very brief. 4.76e+09. In the year 2005, what is the difference between the Cost (current US$) in CO2 damage and Cost (current US$) in Minerals?
Make the answer very short. 9.31e+08. In the year 2005, what is the difference between the Cost (current US$) in CO2 damage and Cost (current US$) in Energy?
Provide a succinct answer. -3.08e+08. In the year 2005, what is the difference between the Cost (current US$) of CO2 damage and Cost (current US$) of Forest?
Provide a succinct answer. 2.72e+09. In the year 2005, what is the difference between the Cost (current US$) in Minerals and Cost (current US$) in Energy?
Offer a very short reply. -1.24e+09. In the year 2005, what is the difference between the Cost (current US$) of Minerals and Cost (current US$) of Forest?
Provide a short and direct response. 1.79e+09. In the year 2005, what is the difference between the Cost (current US$) of Energy and Cost (current US$) of Forest?
Make the answer very short. 3.03e+09. In the year 2006, what is the difference between the Cost (current US$) in CO2 damage and Cost (current US$) in Minerals?
Give a very brief answer. -4.21e+07. In the year 2006, what is the difference between the Cost (current US$) of CO2 damage and Cost (current US$) of Energy?
Offer a terse response. 2.94e+08. In the year 2006, what is the difference between the Cost (current US$) of CO2 damage and Cost (current US$) of Forest?
Give a very brief answer. 3.00e+09. In the year 2006, what is the difference between the Cost (current US$) of Minerals and Cost (current US$) of Energy?
Provide a short and direct response. 3.36e+08. In the year 2006, what is the difference between the Cost (current US$) in Minerals and Cost (current US$) in Forest?
Offer a very short reply. 3.04e+09. In the year 2006, what is the difference between the Cost (current US$) in Energy and Cost (current US$) in Forest?
Your answer should be compact. 2.70e+09. In the year 2007, what is the difference between the Cost (current US$) in CO2 damage and Cost (current US$) in Minerals?
Give a very brief answer. -1.76e+09. In the year 2007, what is the difference between the Cost (current US$) of CO2 damage and Cost (current US$) of Energy?
Your answer should be very brief. 4.65e+08. In the year 2007, what is the difference between the Cost (current US$) of CO2 damage and Cost (current US$) of Forest?
Your response must be concise. 3.46e+09. In the year 2007, what is the difference between the Cost (current US$) of Minerals and Cost (current US$) of Energy?
Your response must be concise. 2.23e+09. In the year 2007, what is the difference between the Cost (current US$) in Minerals and Cost (current US$) in Forest?
Your response must be concise. 5.22e+09. In the year 2007, what is the difference between the Cost (current US$) in Energy and Cost (current US$) in Forest?
Give a very brief answer. 2.99e+09. What is the ratio of the Cost (current US$) in CO2 damage in 1999 to that in 2000?
Ensure brevity in your answer.  0.97. What is the ratio of the Cost (current US$) of Minerals in 1999 to that in 2000?
Keep it short and to the point. 0.66. What is the ratio of the Cost (current US$) of Energy in 1999 to that in 2000?
Offer a terse response. 0.51. What is the ratio of the Cost (current US$) in Forest in 1999 to that in 2000?
Offer a very short reply. 0.75. What is the ratio of the Cost (current US$) in CO2 damage in 1999 to that in 2001?
Provide a succinct answer. 0.96. What is the ratio of the Cost (current US$) in Minerals in 1999 to that in 2001?
Your answer should be compact. 0.68. What is the ratio of the Cost (current US$) of Energy in 1999 to that in 2001?
Your answer should be very brief. 0.28. What is the ratio of the Cost (current US$) in Forest in 1999 to that in 2001?
Offer a terse response. 0.84. What is the ratio of the Cost (current US$) in CO2 damage in 1999 to that in 2002?
Keep it short and to the point. 0.97. What is the ratio of the Cost (current US$) of Minerals in 1999 to that in 2002?
Give a very brief answer. 0.4. What is the ratio of the Cost (current US$) in Energy in 1999 to that in 2002?
Give a very brief answer. 0.28. What is the ratio of the Cost (current US$) in Forest in 1999 to that in 2002?
Provide a succinct answer. 0.69. What is the ratio of the Cost (current US$) in CO2 damage in 1999 to that in 2003?
Your answer should be compact. 0.86. What is the ratio of the Cost (current US$) of Minerals in 1999 to that in 2003?
Give a very brief answer. 0.22. What is the ratio of the Cost (current US$) of Energy in 1999 to that in 2003?
Provide a succinct answer. 0.24. What is the ratio of the Cost (current US$) in Forest in 1999 to that in 2003?
Ensure brevity in your answer.  0.42. What is the ratio of the Cost (current US$) in CO2 damage in 1999 to that in 2004?
Make the answer very short. 0.74. What is the ratio of the Cost (current US$) of Minerals in 1999 to that in 2004?
Offer a very short reply. 0.16. What is the ratio of the Cost (current US$) in Energy in 1999 to that in 2004?
Your response must be concise. 0.04. What is the ratio of the Cost (current US$) of Forest in 1999 to that in 2004?
Your answer should be very brief. 0.54. What is the ratio of the Cost (current US$) in CO2 damage in 1999 to that in 2005?
Give a very brief answer. 0.77. What is the ratio of the Cost (current US$) in Minerals in 1999 to that in 2005?
Ensure brevity in your answer.  0.11. What is the ratio of the Cost (current US$) of Energy in 1999 to that in 2005?
Offer a very short reply. 0.06. What is the ratio of the Cost (current US$) in Forest in 1999 to that in 2005?
Provide a succinct answer. 0.4. What is the ratio of the Cost (current US$) of CO2 damage in 1999 to that in 2006?
Your answer should be very brief. 0.68. What is the ratio of the Cost (current US$) in Minerals in 1999 to that in 2006?
Your answer should be very brief. 0.07. What is the ratio of the Cost (current US$) in Energy in 1999 to that in 2006?
Your response must be concise. 0.06. What is the ratio of the Cost (current US$) in Forest in 1999 to that in 2006?
Keep it short and to the point. 0.32. What is the ratio of the Cost (current US$) in CO2 damage in 1999 to that in 2007?
Give a very brief answer. 0.63. What is the ratio of the Cost (current US$) in Minerals in 1999 to that in 2007?
Your answer should be compact. 0.04. What is the ratio of the Cost (current US$) of Energy in 1999 to that in 2007?
Your answer should be compact. 0.06. What is the ratio of the Cost (current US$) in Forest in 1999 to that in 2007?
Keep it short and to the point. 0.45. What is the ratio of the Cost (current US$) of CO2 damage in 2000 to that in 2001?
Give a very brief answer. 0.98. What is the ratio of the Cost (current US$) of Minerals in 2000 to that in 2001?
Offer a terse response. 1.03. What is the ratio of the Cost (current US$) in Energy in 2000 to that in 2001?
Ensure brevity in your answer.  0.55. What is the ratio of the Cost (current US$) in Forest in 2000 to that in 2001?
Provide a short and direct response. 1.12. What is the ratio of the Cost (current US$) in CO2 damage in 2000 to that in 2002?
Provide a short and direct response. 1. What is the ratio of the Cost (current US$) in Minerals in 2000 to that in 2002?
Make the answer very short. 0.6. What is the ratio of the Cost (current US$) in Energy in 2000 to that in 2002?
Your answer should be compact. 0.55. What is the ratio of the Cost (current US$) in Forest in 2000 to that in 2002?
Provide a succinct answer. 0.93. What is the ratio of the Cost (current US$) of CO2 damage in 2000 to that in 2003?
Offer a terse response. 0.88. What is the ratio of the Cost (current US$) in Minerals in 2000 to that in 2003?
Give a very brief answer. 0.34. What is the ratio of the Cost (current US$) of Energy in 2000 to that in 2003?
Make the answer very short. 0.48. What is the ratio of the Cost (current US$) in Forest in 2000 to that in 2003?
Ensure brevity in your answer.  0.56. What is the ratio of the Cost (current US$) of CO2 damage in 2000 to that in 2004?
Offer a very short reply. 0.76. What is the ratio of the Cost (current US$) of Minerals in 2000 to that in 2004?
Offer a very short reply. 0.25. What is the ratio of the Cost (current US$) in Energy in 2000 to that in 2004?
Give a very brief answer. 0.07. What is the ratio of the Cost (current US$) of Forest in 2000 to that in 2004?
Give a very brief answer. 0.72. What is the ratio of the Cost (current US$) in CO2 damage in 2000 to that in 2005?
Offer a very short reply. 0.79. What is the ratio of the Cost (current US$) of Minerals in 2000 to that in 2005?
Keep it short and to the point. 0.16. What is the ratio of the Cost (current US$) of Energy in 2000 to that in 2005?
Your answer should be compact. 0.11. What is the ratio of the Cost (current US$) of Forest in 2000 to that in 2005?
Provide a succinct answer. 0.54. What is the ratio of the Cost (current US$) of CO2 damage in 2000 to that in 2006?
Your response must be concise. 0.7. What is the ratio of the Cost (current US$) in Minerals in 2000 to that in 2006?
Your answer should be very brief. 0.1. What is the ratio of the Cost (current US$) of Energy in 2000 to that in 2006?
Provide a succinct answer. 0.12. What is the ratio of the Cost (current US$) in Forest in 2000 to that in 2006?
Your response must be concise. 0.43. What is the ratio of the Cost (current US$) of CO2 damage in 2000 to that in 2007?
Provide a succinct answer. 0.65. What is the ratio of the Cost (current US$) of Minerals in 2000 to that in 2007?
Give a very brief answer. 0.06. What is the ratio of the Cost (current US$) in Energy in 2000 to that in 2007?
Give a very brief answer. 0.11. What is the ratio of the Cost (current US$) of Forest in 2000 to that in 2007?
Keep it short and to the point. 0.61. What is the ratio of the Cost (current US$) in CO2 damage in 2001 to that in 2002?
Your answer should be very brief. 1.02. What is the ratio of the Cost (current US$) of Minerals in 2001 to that in 2002?
Your response must be concise. 0.59. What is the ratio of the Cost (current US$) in Energy in 2001 to that in 2002?
Your response must be concise. 1.01. What is the ratio of the Cost (current US$) of Forest in 2001 to that in 2002?
Offer a very short reply. 0.83. What is the ratio of the Cost (current US$) of CO2 damage in 2001 to that in 2003?
Your answer should be very brief. 0.9. What is the ratio of the Cost (current US$) in Minerals in 2001 to that in 2003?
Provide a short and direct response. 0.33. What is the ratio of the Cost (current US$) in Energy in 2001 to that in 2003?
Offer a terse response. 0.88. What is the ratio of the Cost (current US$) of Forest in 2001 to that in 2003?
Ensure brevity in your answer.  0.5. What is the ratio of the Cost (current US$) of CO2 damage in 2001 to that in 2004?
Make the answer very short. 0.77. What is the ratio of the Cost (current US$) of Minerals in 2001 to that in 2004?
Offer a terse response. 0.24. What is the ratio of the Cost (current US$) of Energy in 2001 to that in 2004?
Ensure brevity in your answer.  0.14. What is the ratio of the Cost (current US$) of Forest in 2001 to that in 2004?
Provide a short and direct response. 0.65. What is the ratio of the Cost (current US$) in CO2 damage in 2001 to that in 2005?
Your response must be concise. 0.81. What is the ratio of the Cost (current US$) of Minerals in 2001 to that in 2005?
Your response must be concise. 0.16. What is the ratio of the Cost (current US$) in Forest in 2001 to that in 2005?
Offer a very short reply. 0.48. What is the ratio of the Cost (current US$) of CO2 damage in 2001 to that in 2006?
Provide a short and direct response. 0.72. What is the ratio of the Cost (current US$) in Minerals in 2001 to that in 2006?
Your response must be concise. 0.1. What is the ratio of the Cost (current US$) of Energy in 2001 to that in 2006?
Your response must be concise. 0.21. What is the ratio of the Cost (current US$) of Forest in 2001 to that in 2006?
Provide a succinct answer. 0.39. What is the ratio of the Cost (current US$) of CO2 damage in 2001 to that in 2007?
Keep it short and to the point. 0.66. What is the ratio of the Cost (current US$) of Minerals in 2001 to that in 2007?
Your response must be concise. 0.06. What is the ratio of the Cost (current US$) in Energy in 2001 to that in 2007?
Keep it short and to the point. 0.2. What is the ratio of the Cost (current US$) in Forest in 2001 to that in 2007?
Provide a succinct answer. 0.54. What is the ratio of the Cost (current US$) of CO2 damage in 2002 to that in 2003?
Your answer should be compact. 0.88. What is the ratio of the Cost (current US$) of Minerals in 2002 to that in 2003?
Provide a succinct answer. 0.56. What is the ratio of the Cost (current US$) in Energy in 2002 to that in 2003?
Your answer should be compact. 0.87. What is the ratio of the Cost (current US$) of Forest in 2002 to that in 2003?
Give a very brief answer. 0.6. What is the ratio of the Cost (current US$) of CO2 damage in 2002 to that in 2004?
Provide a succinct answer. 0.76. What is the ratio of the Cost (current US$) of Minerals in 2002 to that in 2004?
Keep it short and to the point. 0.41. What is the ratio of the Cost (current US$) of Energy in 2002 to that in 2004?
Give a very brief answer. 0.14. What is the ratio of the Cost (current US$) of Forest in 2002 to that in 2004?
Provide a succinct answer. 0.78. What is the ratio of the Cost (current US$) in CO2 damage in 2002 to that in 2005?
Provide a short and direct response. 0.79. What is the ratio of the Cost (current US$) in Minerals in 2002 to that in 2005?
Ensure brevity in your answer.  0.27. What is the ratio of the Cost (current US$) of Energy in 2002 to that in 2005?
Keep it short and to the point. 0.2. What is the ratio of the Cost (current US$) of Forest in 2002 to that in 2005?
Provide a succinct answer. 0.58. What is the ratio of the Cost (current US$) of CO2 damage in 2002 to that in 2006?
Offer a terse response. 0.71. What is the ratio of the Cost (current US$) in Minerals in 2002 to that in 2006?
Your answer should be very brief. 0.17. What is the ratio of the Cost (current US$) in Energy in 2002 to that in 2006?
Provide a succinct answer. 0.21. What is the ratio of the Cost (current US$) in Forest in 2002 to that in 2006?
Make the answer very short. 0.47. What is the ratio of the Cost (current US$) of CO2 damage in 2002 to that in 2007?
Your answer should be very brief. 0.65. What is the ratio of the Cost (current US$) of Minerals in 2002 to that in 2007?
Provide a succinct answer. 0.11. What is the ratio of the Cost (current US$) in Energy in 2002 to that in 2007?
Offer a very short reply. 0.2. What is the ratio of the Cost (current US$) in Forest in 2002 to that in 2007?
Provide a short and direct response. 0.65. What is the ratio of the Cost (current US$) of CO2 damage in 2003 to that in 2004?
Make the answer very short. 0.86. What is the ratio of the Cost (current US$) in Minerals in 2003 to that in 2004?
Your answer should be very brief. 0.73. What is the ratio of the Cost (current US$) of Energy in 2003 to that in 2004?
Keep it short and to the point. 0.16. What is the ratio of the Cost (current US$) of Forest in 2003 to that in 2004?
Keep it short and to the point. 1.3. What is the ratio of the Cost (current US$) of CO2 damage in 2003 to that in 2005?
Provide a short and direct response. 0.9. What is the ratio of the Cost (current US$) of Minerals in 2003 to that in 2005?
Offer a very short reply. 0.47. What is the ratio of the Cost (current US$) in Energy in 2003 to that in 2005?
Your answer should be very brief. 0.23. What is the ratio of the Cost (current US$) of Forest in 2003 to that in 2005?
Provide a short and direct response. 0.96. What is the ratio of the Cost (current US$) in CO2 damage in 2003 to that in 2006?
Offer a very short reply. 0.8. What is the ratio of the Cost (current US$) in Minerals in 2003 to that in 2006?
Give a very brief answer. 0.29. What is the ratio of the Cost (current US$) of Energy in 2003 to that in 2006?
Keep it short and to the point. 0.24. What is the ratio of the Cost (current US$) in Forest in 2003 to that in 2006?
Provide a short and direct response. 0.77. What is the ratio of the Cost (current US$) of CO2 damage in 2003 to that in 2007?
Give a very brief answer. 0.74. What is the ratio of the Cost (current US$) of Minerals in 2003 to that in 2007?
Give a very brief answer. 0.19. What is the ratio of the Cost (current US$) of Energy in 2003 to that in 2007?
Offer a terse response. 0.23. What is the ratio of the Cost (current US$) of Forest in 2003 to that in 2007?
Provide a short and direct response. 1.09. What is the ratio of the Cost (current US$) in CO2 damage in 2004 to that in 2005?
Provide a short and direct response. 1.04. What is the ratio of the Cost (current US$) of Minerals in 2004 to that in 2005?
Your answer should be compact. 0.65. What is the ratio of the Cost (current US$) in Energy in 2004 to that in 2005?
Make the answer very short. 1.46. What is the ratio of the Cost (current US$) of Forest in 2004 to that in 2005?
Your answer should be compact. 0.74. What is the ratio of the Cost (current US$) in CO2 damage in 2004 to that in 2006?
Offer a terse response. 0.93. What is the ratio of the Cost (current US$) of Minerals in 2004 to that in 2006?
Provide a short and direct response. 0.4. What is the ratio of the Cost (current US$) of Energy in 2004 to that in 2006?
Provide a short and direct response. 1.56. What is the ratio of the Cost (current US$) in Forest in 2004 to that in 2006?
Ensure brevity in your answer.  0.6. What is the ratio of the Cost (current US$) of CO2 damage in 2004 to that in 2007?
Keep it short and to the point. 0.85. What is the ratio of the Cost (current US$) in Minerals in 2004 to that in 2007?
Offer a terse response. 0.26. What is the ratio of the Cost (current US$) in Energy in 2004 to that in 2007?
Your answer should be very brief. 1.5. What is the ratio of the Cost (current US$) in Forest in 2004 to that in 2007?
Keep it short and to the point. 0.84. What is the ratio of the Cost (current US$) of CO2 damage in 2005 to that in 2006?
Your answer should be compact. 0.89. What is the ratio of the Cost (current US$) of Minerals in 2005 to that in 2006?
Give a very brief answer. 0.62. What is the ratio of the Cost (current US$) of Energy in 2005 to that in 2006?
Offer a very short reply. 1.06. What is the ratio of the Cost (current US$) in Forest in 2005 to that in 2006?
Give a very brief answer. 0.81. What is the ratio of the Cost (current US$) of CO2 damage in 2005 to that in 2007?
Make the answer very short. 0.82. What is the ratio of the Cost (current US$) of Minerals in 2005 to that in 2007?
Your response must be concise. 0.4. What is the ratio of the Cost (current US$) in Energy in 2005 to that in 2007?
Your response must be concise. 1.03. What is the ratio of the Cost (current US$) in Forest in 2005 to that in 2007?
Your response must be concise. 1.13. What is the ratio of the Cost (current US$) of CO2 damage in 2006 to that in 2007?
Provide a succinct answer. 0.92. What is the ratio of the Cost (current US$) of Minerals in 2006 to that in 2007?
Your answer should be compact. 0.64. What is the ratio of the Cost (current US$) of Energy in 2006 to that in 2007?
Ensure brevity in your answer.  0.96. What is the ratio of the Cost (current US$) of Forest in 2006 to that in 2007?
Your answer should be compact. 1.4. What is the difference between the highest and the second highest Cost (current US$) of CO2 damage?
Your response must be concise. 2.96e+08. What is the difference between the highest and the second highest Cost (current US$) of Minerals?
Ensure brevity in your answer.  2.02e+09. What is the difference between the highest and the second highest Cost (current US$) in Energy?
Make the answer very short. 1.62e+09. What is the difference between the highest and the second highest Cost (current US$) in Forest?
Your response must be concise. 1.09e+08. What is the difference between the highest and the lowest Cost (current US$) of CO2 damage?
Your response must be concise. 1.42e+09. What is the difference between the highest and the lowest Cost (current US$) of Minerals?
Your answer should be very brief. 5.39e+09. What is the difference between the highest and the lowest Cost (current US$) of Energy?
Offer a terse response. 4.91e+09. What is the difference between the highest and the lowest Cost (current US$) of Forest?
Ensure brevity in your answer.  3.85e+08. 